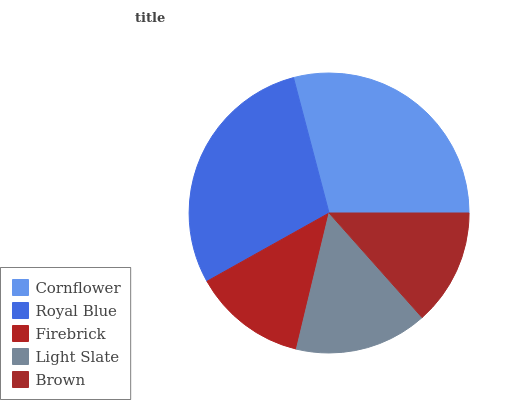Is Firebrick the minimum?
Answer yes or no. Yes. Is Cornflower the maximum?
Answer yes or no. Yes. Is Royal Blue the minimum?
Answer yes or no. No. Is Royal Blue the maximum?
Answer yes or no. No. Is Cornflower greater than Royal Blue?
Answer yes or no. Yes. Is Royal Blue less than Cornflower?
Answer yes or no. Yes. Is Royal Blue greater than Cornflower?
Answer yes or no. No. Is Cornflower less than Royal Blue?
Answer yes or no. No. Is Light Slate the high median?
Answer yes or no. Yes. Is Light Slate the low median?
Answer yes or no. Yes. Is Brown the high median?
Answer yes or no. No. Is Cornflower the low median?
Answer yes or no. No. 